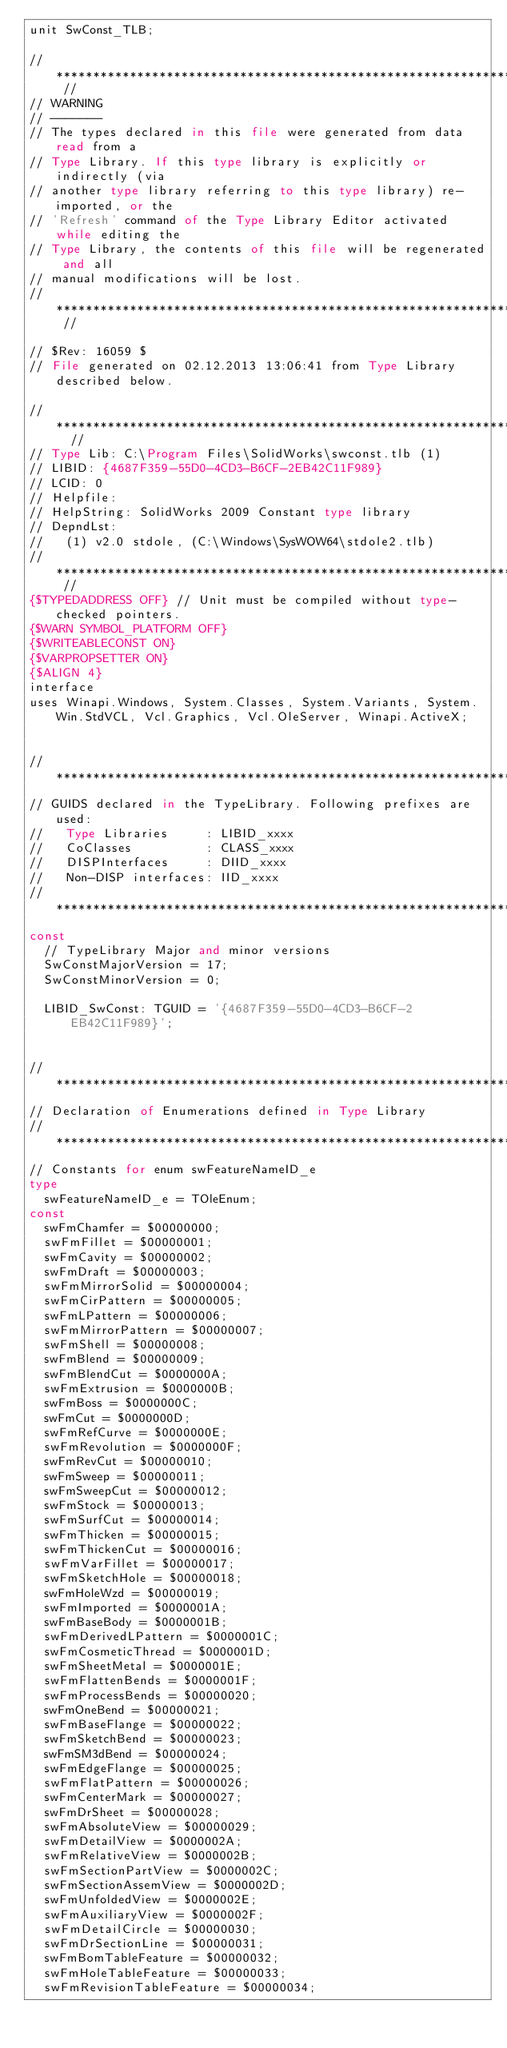<code> <loc_0><loc_0><loc_500><loc_500><_Pascal_>unit SwConst_TLB;

// ************************************************************************ //
// WARNING                                                                    
// -------                                                                    
// The types declared in this file were generated from data read from a       
// Type Library. If this type library is explicitly or indirectly (via        
// another type library referring to this type library) re-imported, or the   
// 'Refresh' command of the Type Library Editor activated while editing the   
// Type Library, the contents of this file will be regenerated and all        
// manual modifications will be lost.                                         
// ************************************************************************ //

// $Rev: 16059 $
// File generated on 02.12.2013 13:06:41 from Type Library described below.

// ************************************************************************  //
// Type Lib: C:\Program Files\SolidWorks\swconst.tlb (1)
// LIBID: {4687F359-55D0-4CD3-B6CF-2EB42C11F989}
// LCID: 0
// Helpfile: 
// HelpString: SolidWorks 2009 Constant type library
// DepndLst: 
//   (1) v2.0 stdole, (C:\Windows\SysWOW64\stdole2.tlb)
// ************************************************************************ //
{$TYPEDADDRESS OFF} // Unit must be compiled without type-checked pointers. 
{$WARN SYMBOL_PLATFORM OFF}
{$WRITEABLECONST ON}
{$VARPROPSETTER ON}
{$ALIGN 4}
interface
uses Winapi.Windows, System.Classes, System.Variants, System.Win.StdVCL, Vcl.Graphics, Vcl.OleServer, Winapi.ActiveX;


// *********************************************************************//
// GUIDS declared in the TypeLibrary. Following prefixes are used:        
//   Type Libraries     : LIBID_xxxx                                      
//   CoClasses          : CLASS_xxxx                                      
//   DISPInterfaces     : DIID_xxxx                                       
//   Non-DISP interfaces: IID_xxxx                                        
// *********************************************************************//
const
  // TypeLibrary Major and minor versions
  SwConstMajorVersion = 17;
  SwConstMinorVersion = 0;

  LIBID_SwConst: TGUID = '{4687F359-55D0-4CD3-B6CF-2EB42C11F989}';


// *********************************************************************//
// Declaration of Enumerations defined in Type Library                    
// *********************************************************************//
// Constants for enum swFeatureNameID_e
type
  swFeatureNameID_e = TOleEnum;
const
  swFmChamfer = $00000000;
  swFmFillet = $00000001;
  swFmCavity = $00000002;
  swFmDraft = $00000003;
  swFmMirrorSolid = $00000004;
  swFmCirPattern = $00000005;
  swFmLPattern = $00000006;
  swFmMirrorPattern = $00000007;
  swFmShell = $00000008;
  swFmBlend = $00000009;
  swFmBlendCut = $0000000A;
  swFmExtrusion = $0000000B;
  swFmBoss = $0000000C;
  swFmCut = $0000000D;
  swFmRefCurve = $0000000E;
  swFmRevolution = $0000000F;
  swFmRevCut = $00000010;
  swFmSweep = $00000011;
  swFmSweepCut = $00000012;
  swFmStock = $00000013;
  swFmSurfCut = $00000014;
  swFmThicken = $00000015;
  swFmThickenCut = $00000016;
  swFmVarFillet = $00000017;
  swFmSketchHole = $00000018;
  swFmHoleWzd = $00000019;
  swFmImported = $0000001A;
  swFmBaseBody = $0000001B;
  swFmDerivedLPattern = $0000001C;
  swFmCosmeticThread = $0000001D;
  swFmSheetMetal = $0000001E;
  swFmFlattenBends = $0000001F;
  swFmProcessBends = $00000020;
  swFmOneBend = $00000021;
  swFmBaseFlange = $00000022;
  swFmSketchBend = $00000023;
  swFmSM3dBend = $00000024;
  swFmEdgeFlange = $00000025;
  swFmFlatPattern = $00000026;
  swFmCenterMark = $00000027;
  swFmDrSheet = $00000028;
  swFmAbsoluteView = $00000029;
  swFmDetailView = $0000002A;
  swFmRelativeView = $0000002B;
  swFmSectionPartView = $0000002C;
  swFmSectionAssemView = $0000002D;
  swFmUnfoldedView = $0000002E;
  swFmAuxiliaryView = $0000002F;
  swFmDetailCircle = $00000030;
  swFmDrSectionLine = $00000031;
  swFmBomTableFeature = $00000032;
  swFmHoleTableFeature = $00000033;
  swFmRevisionTableFeature = $00000034;</code> 